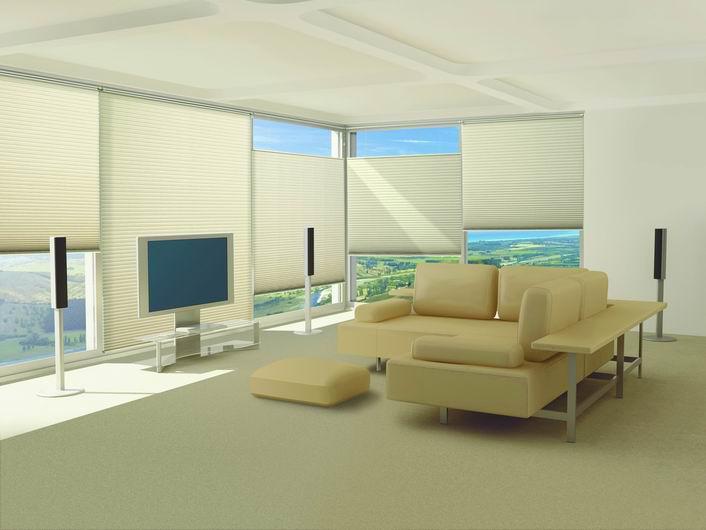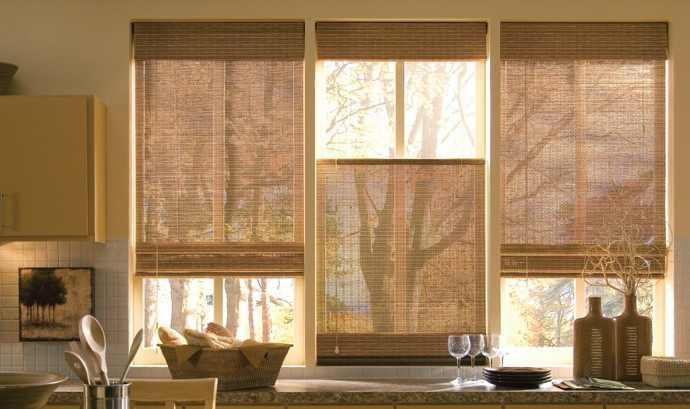The first image is the image on the left, the second image is the image on the right. Examine the images to the left and right. Is the description "There are eight blinds." accurate? Answer yes or no. Yes. The first image is the image on the left, the second image is the image on the right. Analyze the images presented: Is the assertion "There are exactly three shades in the right image." valid? Answer yes or no. Yes. 